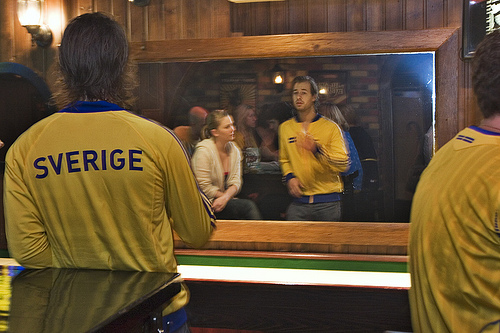<image>
Is there a guy behind the girl? No. The guy is not behind the girl. From this viewpoint, the guy appears to be positioned elsewhere in the scene. 